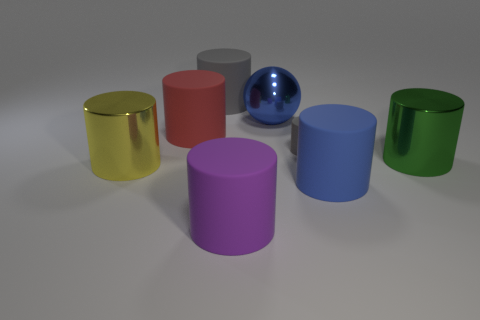Subtract all gray matte cylinders. How many cylinders are left? 5 Subtract all gray cylinders. How many cylinders are left? 5 Add 2 small gray things. How many objects exist? 10 Subtract 0 cyan blocks. How many objects are left? 8 Subtract all balls. How many objects are left? 7 Subtract 5 cylinders. How many cylinders are left? 2 Subtract all yellow cylinders. Subtract all gray balls. How many cylinders are left? 6 Subtract all brown spheres. How many red cylinders are left? 1 Subtract all large blue cylinders. Subtract all large purple matte things. How many objects are left? 6 Add 5 green cylinders. How many green cylinders are left? 6 